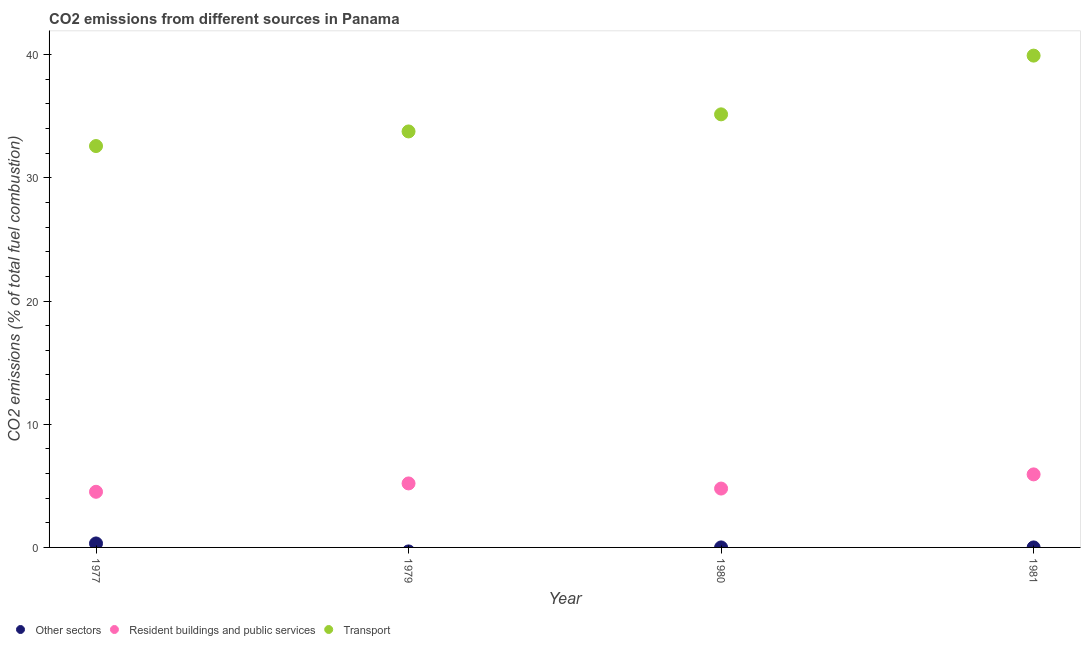How many different coloured dotlines are there?
Provide a short and direct response. 3. What is the percentage of co2 emissions from resident buildings and public services in 1981?
Your response must be concise. 5.93. Across all years, what is the maximum percentage of co2 emissions from transport?
Provide a succinct answer. 39.92. Across all years, what is the minimum percentage of co2 emissions from resident buildings and public services?
Your response must be concise. 4.52. In which year was the percentage of co2 emissions from other sectors maximum?
Your response must be concise. 1977. What is the total percentage of co2 emissions from transport in the graph?
Provide a short and direct response. 141.42. What is the difference between the percentage of co2 emissions from transport in 1977 and that in 1981?
Your answer should be compact. -7.34. What is the difference between the percentage of co2 emissions from other sectors in 1979 and the percentage of co2 emissions from resident buildings and public services in 1981?
Make the answer very short. -5.93. What is the average percentage of co2 emissions from transport per year?
Your answer should be compact. 35.36. In the year 1977, what is the difference between the percentage of co2 emissions from resident buildings and public services and percentage of co2 emissions from other sectors?
Ensure brevity in your answer.  4.19. In how many years, is the percentage of co2 emissions from resident buildings and public services greater than 18 %?
Keep it short and to the point. 0. What is the ratio of the percentage of co2 emissions from transport in 1977 to that in 1979?
Make the answer very short. 0.96. Is the difference between the percentage of co2 emissions from resident buildings and public services in 1977 and 1981 greater than the difference between the percentage of co2 emissions from transport in 1977 and 1981?
Give a very brief answer. Yes. What is the difference between the highest and the second highest percentage of co2 emissions from transport?
Give a very brief answer. 4.77. What is the difference between the highest and the lowest percentage of co2 emissions from resident buildings and public services?
Provide a succinct answer. 1.41. Is it the case that in every year, the sum of the percentage of co2 emissions from other sectors and percentage of co2 emissions from resident buildings and public services is greater than the percentage of co2 emissions from transport?
Make the answer very short. No. Does the percentage of co2 emissions from resident buildings and public services monotonically increase over the years?
Make the answer very short. No. Is the percentage of co2 emissions from transport strictly greater than the percentage of co2 emissions from resident buildings and public services over the years?
Offer a very short reply. Yes. How many dotlines are there?
Give a very brief answer. 3. What is the difference between two consecutive major ticks on the Y-axis?
Keep it short and to the point. 10. Are the values on the major ticks of Y-axis written in scientific E-notation?
Make the answer very short. No. Does the graph contain grids?
Ensure brevity in your answer.  No. Where does the legend appear in the graph?
Offer a very short reply. Bottom left. What is the title of the graph?
Ensure brevity in your answer.  CO2 emissions from different sources in Panama. Does "Social Insurance" appear as one of the legend labels in the graph?
Provide a succinct answer. No. What is the label or title of the Y-axis?
Make the answer very short. CO2 emissions (% of total fuel combustion). What is the CO2 emissions (% of total fuel combustion) in Other sectors in 1977?
Make the answer very short. 0.32. What is the CO2 emissions (% of total fuel combustion) of Resident buildings and public services in 1977?
Offer a terse response. 4.52. What is the CO2 emissions (% of total fuel combustion) of Transport in 1977?
Your answer should be compact. 32.58. What is the CO2 emissions (% of total fuel combustion) of Resident buildings and public services in 1979?
Your answer should be very brief. 5.19. What is the CO2 emissions (% of total fuel combustion) in Transport in 1979?
Offer a terse response. 33.77. What is the CO2 emissions (% of total fuel combustion) in Other sectors in 1980?
Provide a short and direct response. 2.36822317539496e-16. What is the CO2 emissions (% of total fuel combustion) of Resident buildings and public services in 1980?
Keep it short and to the point. 4.78. What is the CO2 emissions (% of total fuel combustion) in Transport in 1980?
Your response must be concise. 35.15. What is the CO2 emissions (% of total fuel combustion) of Other sectors in 1981?
Your response must be concise. 0. What is the CO2 emissions (% of total fuel combustion) of Resident buildings and public services in 1981?
Your response must be concise. 5.93. What is the CO2 emissions (% of total fuel combustion) of Transport in 1981?
Offer a terse response. 39.92. Across all years, what is the maximum CO2 emissions (% of total fuel combustion) in Other sectors?
Make the answer very short. 0.32. Across all years, what is the maximum CO2 emissions (% of total fuel combustion) in Resident buildings and public services?
Ensure brevity in your answer.  5.93. Across all years, what is the maximum CO2 emissions (% of total fuel combustion) in Transport?
Make the answer very short. 39.92. Across all years, what is the minimum CO2 emissions (% of total fuel combustion) of Other sectors?
Your answer should be compact. 0. Across all years, what is the minimum CO2 emissions (% of total fuel combustion) of Resident buildings and public services?
Make the answer very short. 4.52. Across all years, what is the minimum CO2 emissions (% of total fuel combustion) in Transport?
Give a very brief answer. 32.58. What is the total CO2 emissions (% of total fuel combustion) of Other sectors in the graph?
Offer a terse response. 0.32. What is the total CO2 emissions (% of total fuel combustion) in Resident buildings and public services in the graph?
Offer a very short reply. 20.42. What is the total CO2 emissions (% of total fuel combustion) of Transport in the graph?
Offer a very short reply. 141.42. What is the difference between the CO2 emissions (% of total fuel combustion) of Resident buildings and public services in 1977 and that in 1979?
Your answer should be very brief. -0.68. What is the difference between the CO2 emissions (% of total fuel combustion) of Transport in 1977 and that in 1979?
Keep it short and to the point. -1.19. What is the difference between the CO2 emissions (% of total fuel combustion) in Other sectors in 1977 and that in 1980?
Your response must be concise. 0.32. What is the difference between the CO2 emissions (% of total fuel combustion) of Resident buildings and public services in 1977 and that in 1980?
Give a very brief answer. -0.26. What is the difference between the CO2 emissions (% of total fuel combustion) in Transport in 1977 and that in 1980?
Offer a terse response. -2.57. What is the difference between the CO2 emissions (% of total fuel combustion) in Resident buildings and public services in 1977 and that in 1981?
Your answer should be compact. -1.41. What is the difference between the CO2 emissions (% of total fuel combustion) of Transport in 1977 and that in 1981?
Keep it short and to the point. -7.34. What is the difference between the CO2 emissions (% of total fuel combustion) of Resident buildings and public services in 1979 and that in 1980?
Provide a succinct answer. 0.42. What is the difference between the CO2 emissions (% of total fuel combustion) of Transport in 1979 and that in 1980?
Keep it short and to the point. -1.39. What is the difference between the CO2 emissions (% of total fuel combustion) in Resident buildings and public services in 1979 and that in 1981?
Provide a succinct answer. -0.73. What is the difference between the CO2 emissions (% of total fuel combustion) in Transport in 1979 and that in 1981?
Provide a succinct answer. -6.15. What is the difference between the CO2 emissions (% of total fuel combustion) of Resident buildings and public services in 1980 and that in 1981?
Give a very brief answer. -1.15. What is the difference between the CO2 emissions (% of total fuel combustion) of Transport in 1980 and that in 1981?
Your response must be concise. -4.77. What is the difference between the CO2 emissions (% of total fuel combustion) of Other sectors in 1977 and the CO2 emissions (% of total fuel combustion) of Resident buildings and public services in 1979?
Provide a short and direct response. -4.87. What is the difference between the CO2 emissions (% of total fuel combustion) in Other sectors in 1977 and the CO2 emissions (% of total fuel combustion) in Transport in 1979?
Provide a succinct answer. -33.44. What is the difference between the CO2 emissions (% of total fuel combustion) of Resident buildings and public services in 1977 and the CO2 emissions (% of total fuel combustion) of Transport in 1979?
Keep it short and to the point. -29.25. What is the difference between the CO2 emissions (% of total fuel combustion) in Other sectors in 1977 and the CO2 emissions (% of total fuel combustion) in Resident buildings and public services in 1980?
Provide a short and direct response. -4.46. What is the difference between the CO2 emissions (% of total fuel combustion) in Other sectors in 1977 and the CO2 emissions (% of total fuel combustion) in Transport in 1980?
Keep it short and to the point. -34.83. What is the difference between the CO2 emissions (% of total fuel combustion) in Resident buildings and public services in 1977 and the CO2 emissions (% of total fuel combustion) in Transport in 1980?
Ensure brevity in your answer.  -30.64. What is the difference between the CO2 emissions (% of total fuel combustion) in Other sectors in 1977 and the CO2 emissions (% of total fuel combustion) in Resident buildings and public services in 1981?
Make the answer very short. -5.61. What is the difference between the CO2 emissions (% of total fuel combustion) in Other sectors in 1977 and the CO2 emissions (% of total fuel combustion) in Transport in 1981?
Make the answer very short. -39.6. What is the difference between the CO2 emissions (% of total fuel combustion) in Resident buildings and public services in 1977 and the CO2 emissions (% of total fuel combustion) in Transport in 1981?
Give a very brief answer. -35.4. What is the difference between the CO2 emissions (% of total fuel combustion) of Resident buildings and public services in 1979 and the CO2 emissions (% of total fuel combustion) of Transport in 1980?
Offer a terse response. -29.96. What is the difference between the CO2 emissions (% of total fuel combustion) in Resident buildings and public services in 1979 and the CO2 emissions (% of total fuel combustion) in Transport in 1981?
Offer a terse response. -34.73. What is the difference between the CO2 emissions (% of total fuel combustion) of Other sectors in 1980 and the CO2 emissions (% of total fuel combustion) of Resident buildings and public services in 1981?
Offer a terse response. -5.93. What is the difference between the CO2 emissions (% of total fuel combustion) in Other sectors in 1980 and the CO2 emissions (% of total fuel combustion) in Transport in 1981?
Give a very brief answer. -39.92. What is the difference between the CO2 emissions (% of total fuel combustion) of Resident buildings and public services in 1980 and the CO2 emissions (% of total fuel combustion) of Transport in 1981?
Keep it short and to the point. -35.14. What is the average CO2 emissions (% of total fuel combustion) of Other sectors per year?
Your answer should be compact. 0.08. What is the average CO2 emissions (% of total fuel combustion) of Resident buildings and public services per year?
Keep it short and to the point. 5.1. What is the average CO2 emissions (% of total fuel combustion) of Transport per year?
Ensure brevity in your answer.  35.36. In the year 1977, what is the difference between the CO2 emissions (% of total fuel combustion) of Other sectors and CO2 emissions (% of total fuel combustion) of Resident buildings and public services?
Make the answer very short. -4.19. In the year 1977, what is the difference between the CO2 emissions (% of total fuel combustion) in Other sectors and CO2 emissions (% of total fuel combustion) in Transport?
Your response must be concise. -32.26. In the year 1977, what is the difference between the CO2 emissions (% of total fuel combustion) in Resident buildings and public services and CO2 emissions (% of total fuel combustion) in Transport?
Make the answer very short. -28.06. In the year 1979, what is the difference between the CO2 emissions (% of total fuel combustion) in Resident buildings and public services and CO2 emissions (% of total fuel combustion) in Transport?
Your answer should be very brief. -28.57. In the year 1980, what is the difference between the CO2 emissions (% of total fuel combustion) in Other sectors and CO2 emissions (% of total fuel combustion) in Resident buildings and public services?
Provide a succinct answer. -4.78. In the year 1980, what is the difference between the CO2 emissions (% of total fuel combustion) of Other sectors and CO2 emissions (% of total fuel combustion) of Transport?
Keep it short and to the point. -35.15. In the year 1980, what is the difference between the CO2 emissions (% of total fuel combustion) in Resident buildings and public services and CO2 emissions (% of total fuel combustion) in Transport?
Your response must be concise. -30.38. In the year 1981, what is the difference between the CO2 emissions (% of total fuel combustion) of Resident buildings and public services and CO2 emissions (% of total fuel combustion) of Transport?
Keep it short and to the point. -33.99. What is the ratio of the CO2 emissions (% of total fuel combustion) in Resident buildings and public services in 1977 to that in 1979?
Give a very brief answer. 0.87. What is the ratio of the CO2 emissions (% of total fuel combustion) in Transport in 1977 to that in 1979?
Ensure brevity in your answer.  0.96. What is the ratio of the CO2 emissions (% of total fuel combustion) of Other sectors in 1977 to that in 1980?
Ensure brevity in your answer.  1.36e+15. What is the ratio of the CO2 emissions (% of total fuel combustion) in Resident buildings and public services in 1977 to that in 1980?
Ensure brevity in your answer.  0.95. What is the ratio of the CO2 emissions (% of total fuel combustion) of Transport in 1977 to that in 1980?
Give a very brief answer. 0.93. What is the ratio of the CO2 emissions (% of total fuel combustion) of Resident buildings and public services in 1977 to that in 1981?
Keep it short and to the point. 0.76. What is the ratio of the CO2 emissions (% of total fuel combustion) of Transport in 1977 to that in 1981?
Provide a short and direct response. 0.82. What is the ratio of the CO2 emissions (% of total fuel combustion) in Resident buildings and public services in 1979 to that in 1980?
Your answer should be compact. 1.09. What is the ratio of the CO2 emissions (% of total fuel combustion) of Transport in 1979 to that in 1980?
Offer a very short reply. 0.96. What is the ratio of the CO2 emissions (% of total fuel combustion) of Resident buildings and public services in 1979 to that in 1981?
Give a very brief answer. 0.88. What is the ratio of the CO2 emissions (% of total fuel combustion) in Transport in 1979 to that in 1981?
Offer a terse response. 0.85. What is the ratio of the CO2 emissions (% of total fuel combustion) in Resident buildings and public services in 1980 to that in 1981?
Provide a succinct answer. 0.81. What is the ratio of the CO2 emissions (% of total fuel combustion) in Transport in 1980 to that in 1981?
Provide a succinct answer. 0.88. What is the difference between the highest and the second highest CO2 emissions (% of total fuel combustion) in Resident buildings and public services?
Provide a succinct answer. 0.73. What is the difference between the highest and the second highest CO2 emissions (% of total fuel combustion) of Transport?
Ensure brevity in your answer.  4.77. What is the difference between the highest and the lowest CO2 emissions (% of total fuel combustion) of Other sectors?
Provide a short and direct response. 0.32. What is the difference between the highest and the lowest CO2 emissions (% of total fuel combustion) of Resident buildings and public services?
Keep it short and to the point. 1.41. What is the difference between the highest and the lowest CO2 emissions (% of total fuel combustion) in Transport?
Make the answer very short. 7.34. 